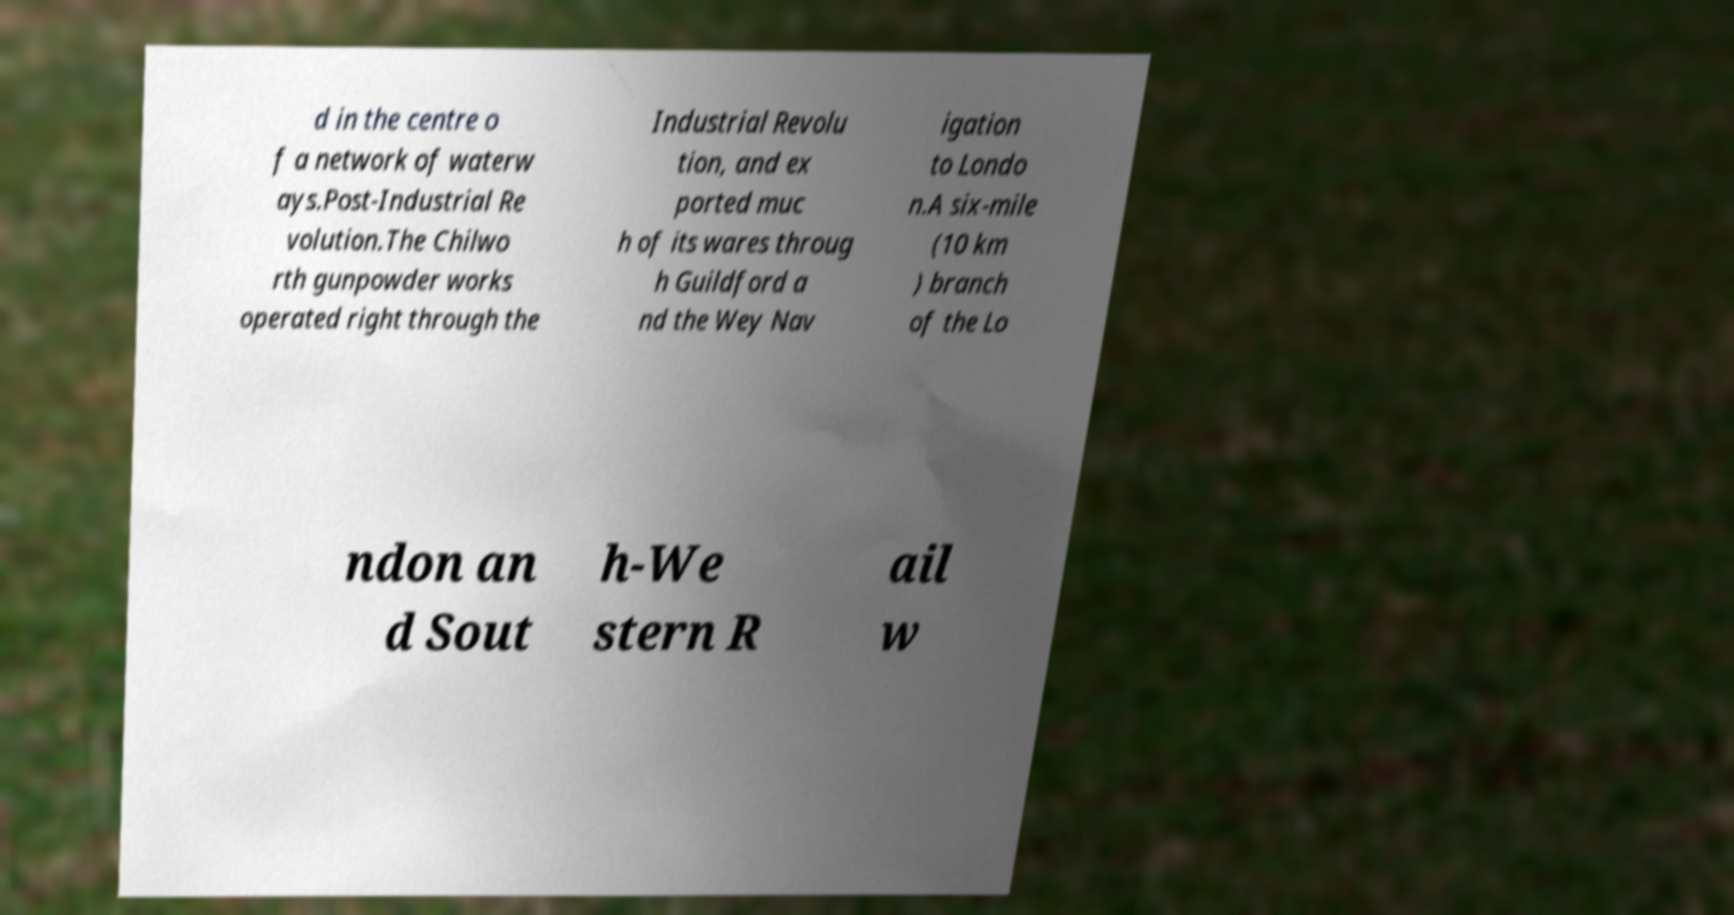Can you accurately transcribe the text from the provided image for me? d in the centre o f a network of waterw ays.Post-Industrial Re volution.The Chilwo rth gunpowder works operated right through the Industrial Revolu tion, and ex ported muc h of its wares throug h Guildford a nd the Wey Nav igation to Londo n.A six-mile (10 km ) branch of the Lo ndon an d Sout h-We stern R ail w 